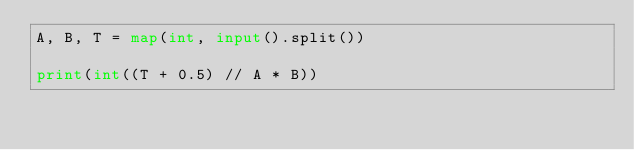Convert code to text. <code><loc_0><loc_0><loc_500><loc_500><_Python_>A, B, T = map(int, input().split())

print(int((T + 0.5) // A * B))</code> 